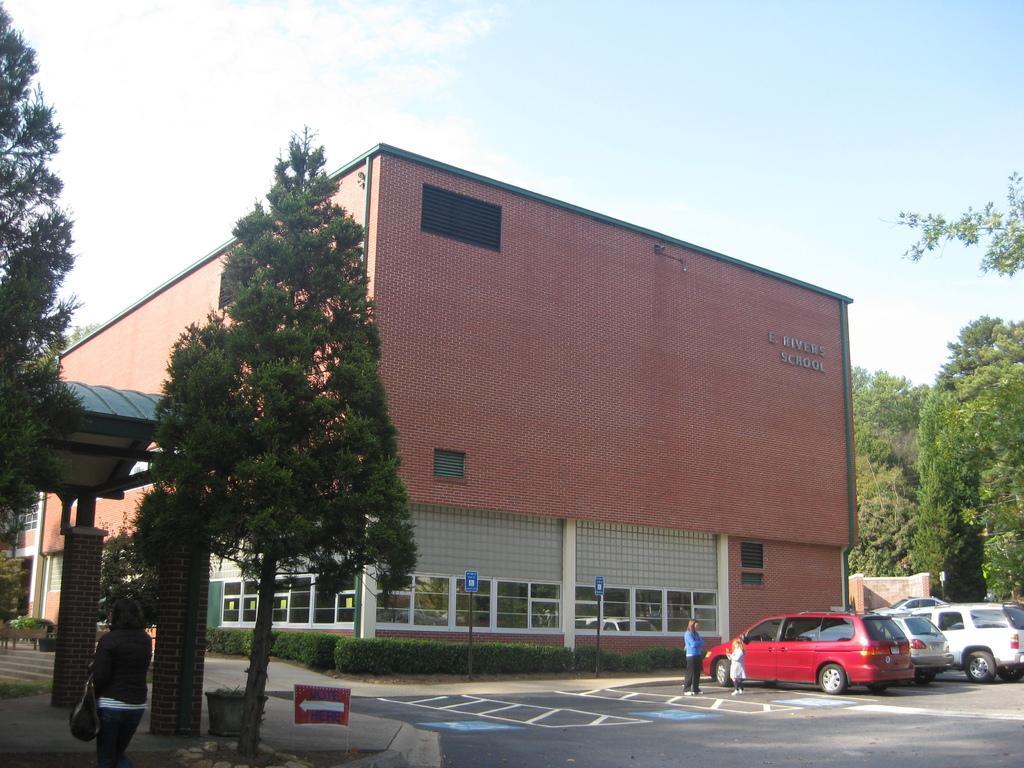In one or two sentences, can you explain what this image depicts? In this picture we can see cars on the right side, on the left side and right side there are trees, we can see a building in the middle, there are some shrubs in front of a building, we can see two persons standing behind the car, there is the sky at the top of the picture, on the left side there is another person. 